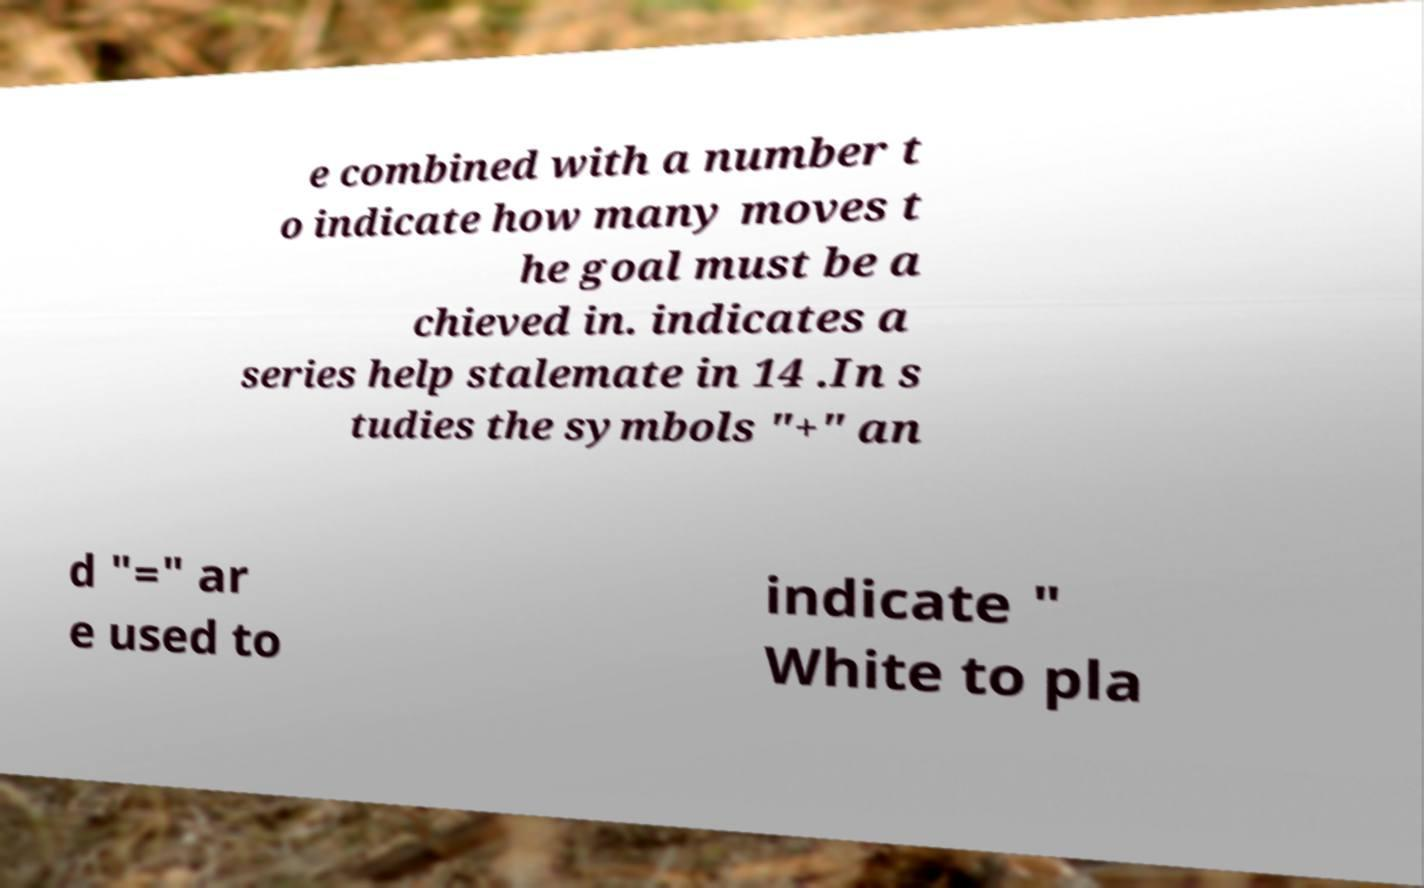I need the written content from this picture converted into text. Can you do that? e combined with a number t o indicate how many moves t he goal must be a chieved in. indicates a series help stalemate in 14 .In s tudies the symbols "+" an d "=" ar e used to indicate " White to pla 